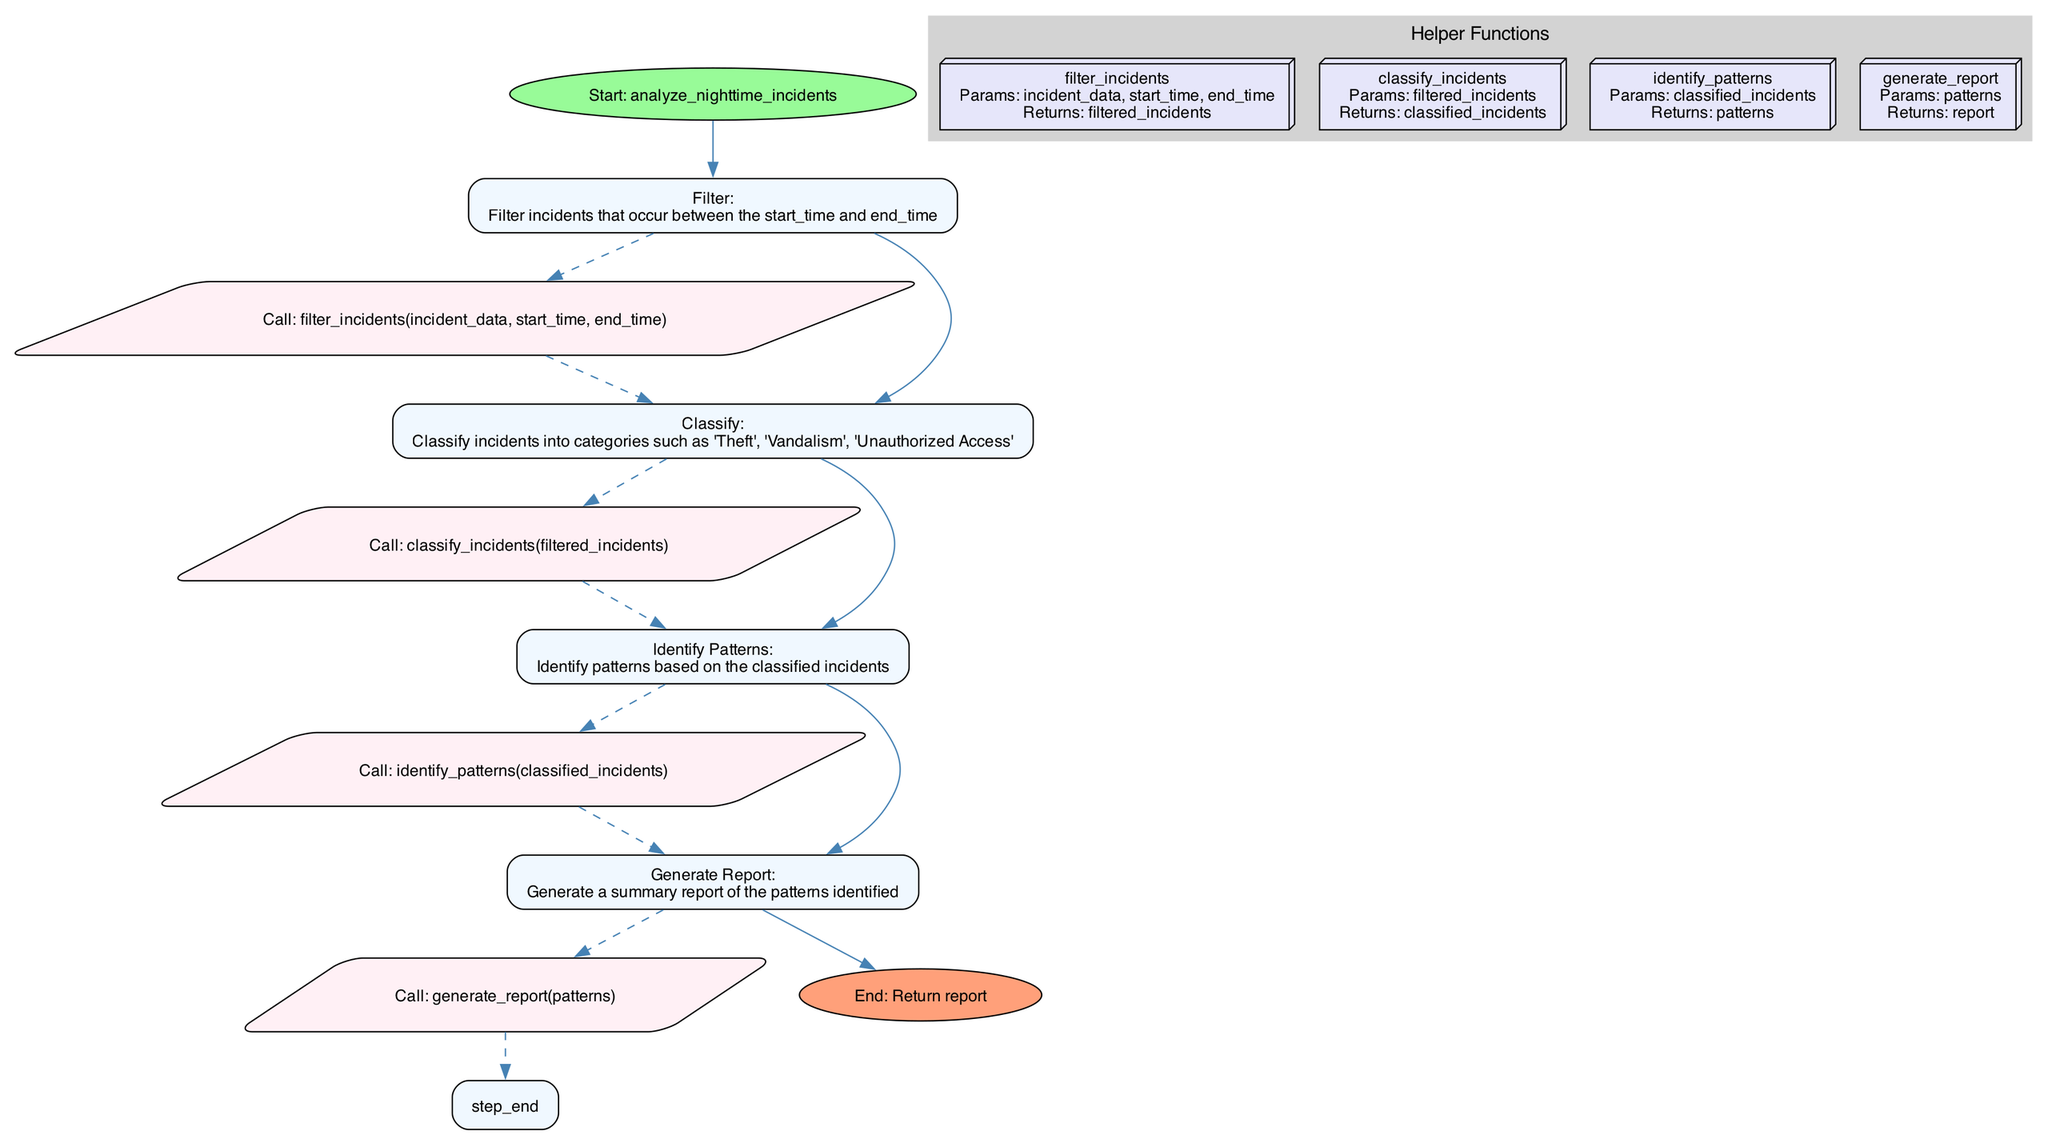What is the first operation in the function? The first operation is represented as a node in the diagram, specifically under "step_0". It is labeled as "Filter:" followed by the description of filtering incidents based on time.
Answer: Filter How many helper functions are there in the diagram? The diagram visually represents four helper functions, each depicted in the "Helper Functions" subgraph.
Answer: Four What does the 'Generate Report' step do? This step is clearly labeled in the diagram as "Generate Report: Generate a summary report of the patterns identified". It summarizes the findings based on previous analyses.
Answer: Generate a summary report of the patterns identified What operation comes after classifying incidents? By tracking the flow from the 'Classify' step, the next operation in the sequence is 'Identify Patterns', indicating a logical order of operations based on the diagram.
Answer: Identify Patterns What is the last operation before the end node? The last operation preceding the end node is 'Generate Report', as it is the final action taken in the function before returning the report.
Answer: Generate Report Which helper function is called to classify incidents? The diagram shows that the 'classify_incidents' function is called right after the 'Filter' step, specifically linked to the 'Classify' operation in the flow.
Answer: classify_incidents How is the 'Identify Patterns' operation connected to the previous operation? The 'Identify Patterns' operation is connected to the 'Classify' operation by a directed edge, following the standard flow through the diagram to indicate the order of operations.
Answer: By a directed edge Which node generates a return? The end node indicates the return in the process. It is the termination point of the flowchart signifying that a report will be returned as the output of the main function.
Answer: End: Return report 